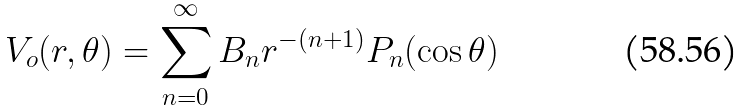Convert formula to latex. <formula><loc_0><loc_0><loc_500><loc_500>V _ { o } ( r , \theta ) = \sum _ { n = 0 } ^ { \infty } B _ { n } r ^ { - ( n + 1 ) } P _ { n } ( \cos \theta )</formula> 